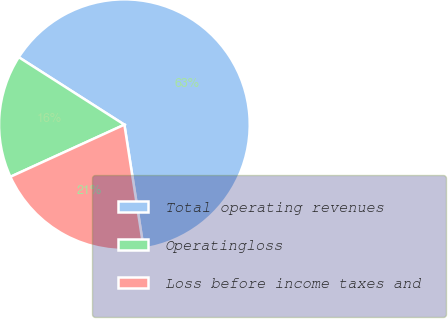<chart> <loc_0><loc_0><loc_500><loc_500><pie_chart><fcel>Total operating revenues<fcel>Operatingloss<fcel>Loss before income taxes and<nl><fcel>63.49%<fcel>15.87%<fcel>20.63%<nl></chart> 